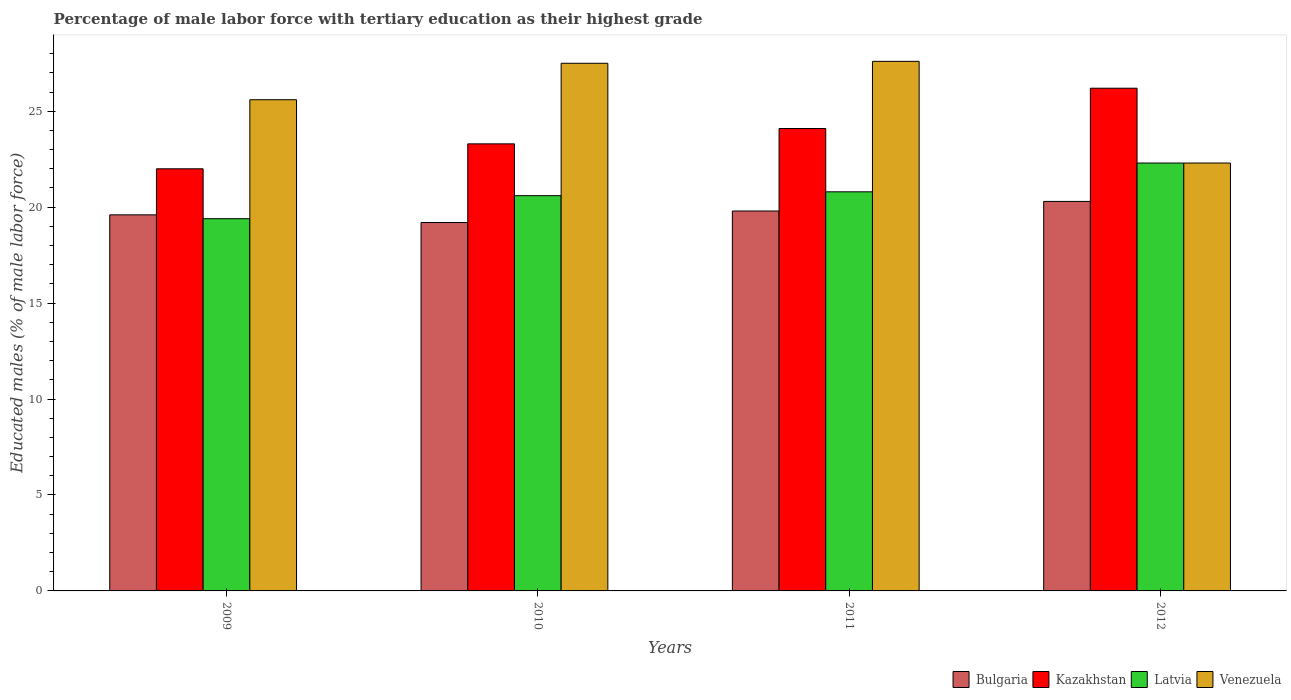How many groups of bars are there?
Your answer should be very brief. 4. Are the number of bars on each tick of the X-axis equal?
Your response must be concise. Yes. How many bars are there on the 2nd tick from the left?
Offer a terse response. 4. In how many cases, is the number of bars for a given year not equal to the number of legend labels?
Give a very brief answer. 0. What is the percentage of male labor force with tertiary education in Venezuela in 2009?
Your answer should be compact. 25.6. Across all years, what is the maximum percentage of male labor force with tertiary education in Latvia?
Ensure brevity in your answer.  22.3. Across all years, what is the minimum percentage of male labor force with tertiary education in Latvia?
Provide a succinct answer. 19.4. In which year was the percentage of male labor force with tertiary education in Venezuela maximum?
Your answer should be very brief. 2011. In which year was the percentage of male labor force with tertiary education in Venezuela minimum?
Provide a short and direct response. 2012. What is the total percentage of male labor force with tertiary education in Venezuela in the graph?
Your answer should be compact. 103. What is the difference between the percentage of male labor force with tertiary education in Venezuela in 2009 and that in 2012?
Offer a terse response. 3.3. What is the difference between the percentage of male labor force with tertiary education in Bulgaria in 2011 and the percentage of male labor force with tertiary education in Latvia in 2009?
Ensure brevity in your answer.  0.4. What is the average percentage of male labor force with tertiary education in Bulgaria per year?
Your answer should be very brief. 19.72. In the year 2010, what is the difference between the percentage of male labor force with tertiary education in Venezuela and percentage of male labor force with tertiary education in Kazakhstan?
Ensure brevity in your answer.  4.2. What is the ratio of the percentage of male labor force with tertiary education in Venezuela in 2010 to that in 2012?
Provide a succinct answer. 1.23. Is the difference between the percentage of male labor force with tertiary education in Venezuela in 2009 and 2012 greater than the difference between the percentage of male labor force with tertiary education in Kazakhstan in 2009 and 2012?
Offer a very short reply. Yes. What is the difference between the highest and the second highest percentage of male labor force with tertiary education in Venezuela?
Make the answer very short. 0.1. What is the difference between the highest and the lowest percentage of male labor force with tertiary education in Latvia?
Your response must be concise. 2.9. In how many years, is the percentage of male labor force with tertiary education in Venezuela greater than the average percentage of male labor force with tertiary education in Venezuela taken over all years?
Your answer should be very brief. 2. Is the sum of the percentage of male labor force with tertiary education in Kazakhstan in 2010 and 2011 greater than the maximum percentage of male labor force with tertiary education in Venezuela across all years?
Your answer should be compact. Yes. Is it the case that in every year, the sum of the percentage of male labor force with tertiary education in Latvia and percentage of male labor force with tertiary education in Bulgaria is greater than the sum of percentage of male labor force with tertiary education in Venezuela and percentage of male labor force with tertiary education in Kazakhstan?
Your answer should be very brief. No. Is it the case that in every year, the sum of the percentage of male labor force with tertiary education in Bulgaria and percentage of male labor force with tertiary education in Venezuela is greater than the percentage of male labor force with tertiary education in Kazakhstan?
Make the answer very short. Yes. How many bars are there?
Offer a terse response. 16. Are all the bars in the graph horizontal?
Offer a terse response. No. What is the difference between two consecutive major ticks on the Y-axis?
Offer a very short reply. 5. Does the graph contain any zero values?
Offer a very short reply. No. What is the title of the graph?
Give a very brief answer. Percentage of male labor force with tertiary education as their highest grade. Does "Eritrea" appear as one of the legend labels in the graph?
Make the answer very short. No. What is the label or title of the X-axis?
Provide a short and direct response. Years. What is the label or title of the Y-axis?
Offer a terse response. Educated males (% of male labor force). What is the Educated males (% of male labor force) of Bulgaria in 2009?
Make the answer very short. 19.6. What is the Educated males (% of male labor force) in Kazakhstan in 2009?
Provide a short and direct response. 22. What is the Educated males (% of male labor force) of Latvia in 2009?
Provide a succinct answer. 19.4. What is the Educated males (% of male labor force) in Venezuela in 2009?
Your answer should be very brief. 25.6. What is the Educated males (% of male labor force) in Bulgaria in 2010?
Your response must be concise. 19.2. What is the Educated males (% of male labor force) of Kazakhstan in 2010?
Ensure brevity in your answer.  23.3. What is the Educated males (% of male labor force) in Latvia in 2010?
Provide a short and direct response. 20.6. What is the Educated males (% of male labor force) of Venezuela in 2010?
Your response must be concise. 27.5. What is the Educated males (% of male labor force) in Bulgaria in 2011?
Your answer should be very brief. 19.8. What is the Educated males (% of male labor force) of Kazakhstan in 2011?
Keep it short and to the point. 24.1. What is the Educated males (% of male labor force) in Latvia in 2011?
Your response must be concise. 20.8. What is the Educated males (% of male labor force) in Venezuela in 2011?
Ensure brevity in your answer.  27.6. What is the Educated males (% of male labor force) of Bulgaria in 2012?
Keep it short and to the point. 20.3. What is the Educated males (% of male labor force) in Kazakhstan in 2012?
Give a very brief answer. 26.2. What is the Educated males (% of male labor force) of Latvia in 2012?
Give a very brief answer. 22.3. What is the Educated males (% of male labor force) in Venezuela in 2012?
Your response must be concise. 22.3. Across all years, what is the maximum Educated males (% of male labor force) in Bulgaria?
Your response must be concise. 20.3. Across all years, what is the maximum Educated males (% of male labor force) in Kazakhstan?
Ensure brevity in your answer.  26.2. Across all years, what is the maximum Educated males (% of male labor force) in Latvia?
Your response must be concise. 22.3. Across all years, what is the maximum Educated males (% of male labor force) in Venezuela?
Your answer should be compact. 27.6. Across all years, what is the minimum Educated males (% of male labor force) in Bulgaria?
Give a very brief answer. 19.2. Across all years, what is the minimum Educated males (% of male labor force) in Latvia?
Give a very brief answer. 19.4. Across all years, what is the minimum Educated males (% of male labor force) of Venezuela?
Offer a very short reply. 22.3. What is the total Educated males (% of male labor force) of Bulgaria in the graph?
Your response must be concise. 78.9. What is the total Educated males (% of male labor force) of Kazakhstan in the graph?
Provide a short and direct response. 95.6. What is the total Educated males (% of male labor force) of Latvia in the graph?
Offer a terse response. 83.1. What is the total Educated males (% of male labor force) in Venezuela in the graph?
Offer a terse response. 103. What is the difference between the Educated males (% of male labor force) of Latvia in 2009 and that in 2010?
Make the answer very short. -1.2. What is the difference between the Educated males (% of male labor force) of Venezuela in 2009 and that in 2010?
Offer a very short reply. -1.9. What is the difference between the Educated males (% of male labor force) in Bulgaria in 2009 and that in 2011?
Offer a terse response. -0.2. What is the difference between the Educated males (% of male labor force) in Latvia in 2009 and that in 2011?
Give a very brief answer. -1.4. What is the difference between the Educated males (% of male labor force) of Venezuela in 2009 and that in 2011?
Keep it short and to the point. -2. What is the difference between the Educated males (% of male labor force) in Latvia in 2009 and that in 2012?
Your response must be concise. -2.9. What is the difference between the Educated males (% of male labor force) of Venezuela in 2009 and that in 2012?
Provide a succinct answer. 3.3. What is the difference between the Educated males (% of male labor force) in Kazakhstan in 2010 and that in 2011?
Make the answer very short. -0.8. What is the difference between the Educated males (% of male labor force) in Venezuela in 2010 and that in 2011?
Give a very brief answer. -0.1. What is the difference between the Educated males (% of male labor force) in Kazakhstan in 2010 and that in 2012?
Make the answer very short. -2.9. What is the difference between the Educated males (% of male labor force) in Latvia in 2010 and that in 2012?
Keep it short and to the point. -1.7. What is the difference between the Educated males (% of male labor force) of Venezuela in 2010 and that in 2012?
Your response must be concise. 5.2. What is the difference between the Educated males (% of male labor force) of Latvia in 2011 and that in 2012?
Your answer should be compact. -1.5. What is the difference between the Educated males (% of male labor force) of Venezuela in 2011 and that in 2012?
Your answer should be very brief. 5.3. What is the difference between the Educated males (% of male labor force) in Bulgaria in 2009 and the Educated males (% of male labor force) in Latvia in 2010?
Offer a terse response. -1. What is the difference between the Educated males (% of male labor force) in Kazakhstan in 2009 and the Educated males (% of male labor force) in Venezuela in 2010?
Ensure brevity in your answer.  -5.5. What is the difference between the Educated males (% of male labor force) of Bulgaria in 2009 and the Educated males (% of male labor force) of Venezuela in 2011?
Provide a succinct answer. -8. What is the difference between the Educated males (% of male labor force) of Latvia in 2009 and the Educated males (% of male labor force) of Venezuela in 2011?
Your answer should be compact. -8.2. What is the difference between the Educated males (% of male labor force) in Bulgaria in 2009 and the Educated males (% of male labor force) in Kazakhstan in 2012?
Offer a very short reply. -6.6. What is the difference between the Educated males (% of male labor force) of Bulgaria in 2009 and the Educated males (% of male labor force) of Venezuela in 2012?
Provide a short and direct response. -2.7. What is the difference between the Educated males (% of male labor force) of Kazakhstan in 2009 and the Educated males (% of male labor force) of Venezuela in 2012?
Your answer should be compact. -0.3. What is the difference between the Educated males (% of male labor force) in Latvia in 2009 and the Educated males (% of male labor force) in Venezuela in 2012?
Your response must be concise. -2.9. What is the difference between the Educated males (% of male labor force) of Kazakhstan in 2010 and the Educated males (% of male labor force) of Latvia in 2011?
Keep it short and to the point. 2.5. What is the difference between the Educated males (% of male labor force) of Bulgaria in 2010 and the Educated males (% of male labor force) of Kazakhstan in 2012?
Offer a terse response. -7. What is the difference between the Educated males (% of male labor force) in Bulgaria in 2010 and the Educated males (% of male labor force) in Latvia in 2012?
Offer a very short reply. -3.1. What is the difference between the Educated males (% of male labor force) in Kazakhstan in 2010 and the Educated males (% of male labor force) in Latvia in 2012?
Provide a short and direct response. 1. What is the difference between the Educated males (% of male labor force) of Bulgaria in 2011 and the Educated males (% of male labor force) of Kazakhstan in 2012?
Your answer should be very brief. -6.4. What is the difference between the Educated males (% of male labor force) in Bulgaria in 2011 and the Educated males (% of male labor force) in Latvia in 2012?
Provide a short and direct response. -2.5. What is the difference between the Educated males (% of male labor force) in Bulgaria in 2011 and the Educated males (% of male labor force) in Venezuela in 2012?
Provide a short and direct response. -2.5. What is the difference between the Educated males (% of male labor force) of Kazakhstan in 2011 and the Educated males (% of male labor force) of Venezuela in 2012?
Your response must be concise. 1.8. What is the difference between the Educated males (% of male labor force) of Latvia in 2011 and the Educated males (% of male labor force) of Venezuela in 2012?
Provide a short and direct response. -1.5. What is the average Educated males (% of male labor force) in Bulgaria per year?
Offer a terse response. 19.73. What is the average Educated males (% of male labor force) in Kazakhstan per year?
Your answer should be very brief. 23.9. What is the average Educated males (% of male labor force) in Latvia per year?
Provide a short and direct response. 20.77. What is the average Educated males (% of male labor force) of Venezuela per year?
Your response must be concise. 25.75. In the year 2009, what is the difference between the Educated males (% of male labor force) of Bulgaria and Educated males (% of male labor force) of Latvia?
Your answer should be compact. 0.2. In the year 2009, what is the difference between the Educated males (% of male labor force) of Bulgaria and Educated males (% of male labor force) of Venezuela?
Keep it short and to the point. -6. In the year 2009, what is the difference between the Educated males (% of male labor force) in Kazakhstan and Educated males (% of male labor force) in Latvia?
Offer a terse response. 2.6. In the year 2009, what is the difference between the Educated males (% of male labor force) in Latvia and Educated males (% of male labor force) in Venezuela?
Your response must be concise. -6.2. In the year 2010, what is the difference between the Educated males (% of male labor force) in Bulgaria and Educated males (% of male labor force) in Kazakhstan?
Ensure brevity in your answer.  -4.1. In the year 2010, what is the difference between the Educated males (% of male labor force) of Latvia and Educated males (% of male labor force) of Venezuela?
Provide a short and direct response. -6.9. In the year 2011, what is the difference between the Educated males (% of male labor force) of Bulgaria and Educated males (% of male labor force) of Venezuela?
Make the answer very short. -7.8. In the year 2011, what is the difference between the Educated males (% of male labor force) of Kazakhstan and Educated males (% of male labor force) of Latvia?
Your response must be concise. 3.3. In the year 2012, what is the difference between the Educated males (% of male labor force) of Bulgaria and Educated males (% of male labor force) of Kazakhstan?
Make the answer very short. -5.9. In the year 2012, what is the difference between the Educated males (% of male labor force) in Bulgaria and Educated males (% of male labor force) in Latvia?
Ensure brevity in your answer.  -2. In the year 2012, what is the difference between the Educated males (% of male labor force) in Bulgaria and Educated males (% of male labor force) in Venezuela?
Offer a very short reply. -2. In the year 2012, what is the difference between the Educated males (% of male labor force) of Kazakhstan and Educated males (% of male labor force) of Latvia?
Make the answer very short. 3.9. In the year 2012, what is the difference between the Educated males (% of male labor force) of Kazakhstan and Educated males (% of male labor force) of Venezuela?
Provide a succinct answer. 3.9. In the year 2012, what is the difference between the Educated males (% of male labor force) of Latvia and Educated males (% of male labor force) of Venezuela?
Your response must be concise. 0. What is the ratio of the Educated males (% of male labor force) of Bulgaria in 2009 to that in 2010?
Give a very brief answer. 1.02. What is the ratio of the Educated males (% of male labor force) of Kazakhstan in 2009 to that in 2010?
Your response must be concise. 0.94. What is the ratio of the Educated males (% of male labor force) in Latvia in 2009 to that in 2010?
Keep it short and to the point. 0.94. What is the ratio of the Educated males (% of male labor force) in Venezuela in 2009 to that in 2010?
Give a very brief answer. 0.93. What is the ratio of the Educated males (% of male labor force) in Bulgaria in 2009 to that in 2011?
Provide a short and direct response. 0.99. What is the ratio of the Educated males (% of male labor force) of Kazakhstan in 2009 to that in 2011?
Your response must be concise. 0.91. What is the ratio of the Educated males (% of male labor force) of Latvia in 2009 to that in 2011?
Offer a very short reply. 0.93. What is the ratio of the Educated males (% of male labor force) of Venezuela in 2009 to that in 2011?
Your answer should be compact. 0.93. What is the ratio of the Educated males (% of male labor force) in Bulgaria in 2009 to that in 2012?
Keep it short and to the point. 0.97. What is the ratio of the Educated males (% of male labor force) in Kazakhstan in 2009 to that in 2012?
Your answer should be very brief. 0.84. What is the ratio of the Educated males (% of male labor force) in Latvia in 2009 to that in 2012?
Provide a succinct answer. 0.87. What is the ratio of the Educated males (% of male labor force) of Venezuela in 2009 to that in 2012?
Your answer should be compact. 1.15. What is the ratio of the Educated males (% of male labor force) of Bulgaria in 2010 to that in 2011?
Give a very brief answer. 0.97. What is the ratio of the Educated males (% of male labor force) in Kazakhstan in 2010 to that in 2011?
Your answer should be very brief. 0.97. What is the ratio of the Educated males (% of male labor force) in Latvia in 2010 to that in 2011?
Keep it short and to the point. 0.99. What is the ratio of the Educated males (% of male labor force) in Bulgaria in 2010 to that in 2012?
Provide a succinct answer. 0.95. What is the ratio of the Educated males (% of male labor force) in Kazakhstan in 2010 to that in 2012?
Your answer should be compact. 0.89. What is the ratio of the Educated males (% of male labor force) of Latvia in 2010 to that in 2012?
Your response must be concise. 0.92. What is the ratio of the Educated males (% of male labor force) of Venezuela in 2010 to that in 2012?
Provide a short and direct response. 1.23. What is the ratio of the Educated males (% of male labor force) of Bulgaria in 2011 to that in 2012?
Ensure brevity in your answer.  0.98. What is the ratio of the Educated males (% of male labor force) in Kazakhstan in 2011 to that in 2012?
Offer a terse response. 0.92. What is the ratio of the Educated males (% of male labor force) of Latvia in 2011 to that in 2012?
Your answer should be very brief. 0.93. What is the ratio of the Educated males (% of male labor force) of Venezuela in 2011 to that in 2012?
Make the answer very short. 1.24. What is the difference between the highest and the second highest Educated males (% of male labor force) in Bulgaria?
Give a very brief answer. 0.5. What is the difference between the highest and the second highest Educated males (% of male labor force) in Kazakhstan?
Ensure brevity in your answer.  2.1. What is the difference between the highest and the lowest Educated males (% of male labor force) of Venezuela?
Ensure brevity in your answer.  5.3. 